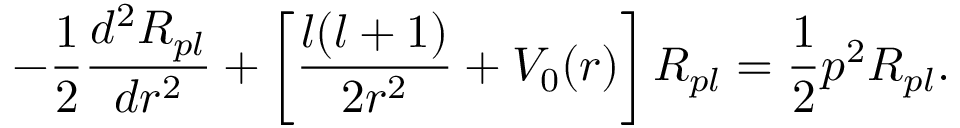Convert formula to latex. <formula><loc_0><loc_0><loc_500><loc_500>- \frac { 1 } { 2 } \frac { d ^ { 2 } R _ { p l } } { d r ^ { 2 } } + \left [ \frac { l ( l + 1 ) } { 2 r ^ { 2 } } + V _ { 0 } ( r ) \right ] R _ { p l } = \frac { 1 } { 2 } p ^ { 2 } R _ { p l } .</formula> 